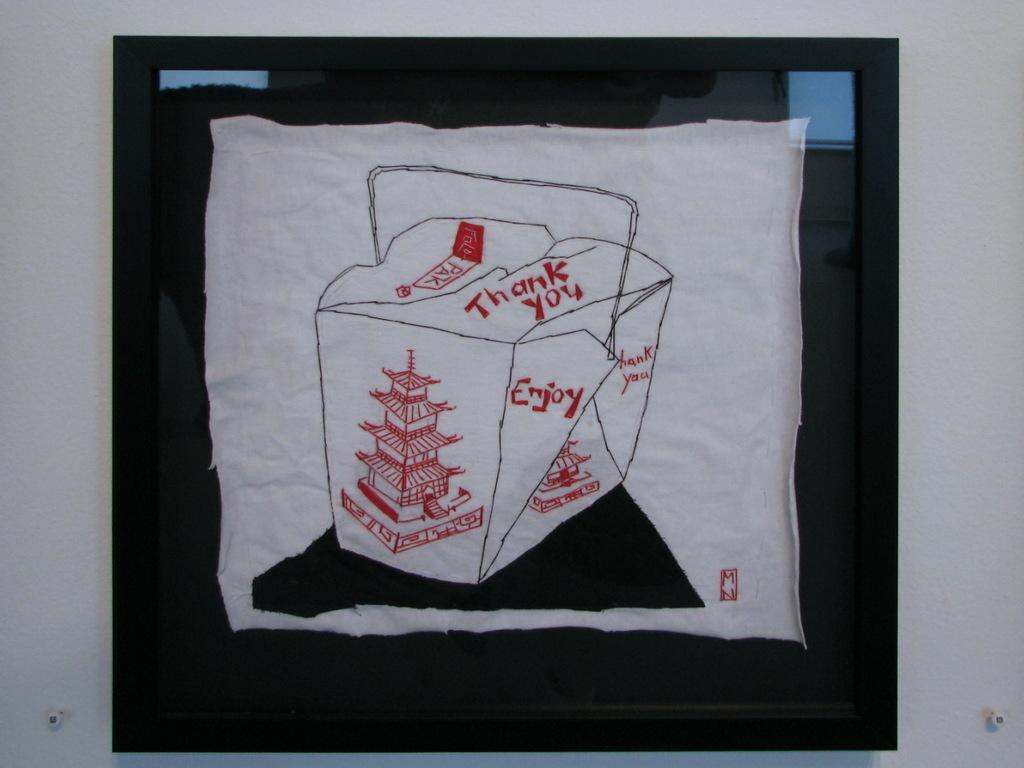What is the color of the wall in the image? The wall in the image is white. What is attached to the wall? There is a black frame on the wall. What is inside the black frame? Inside the frame, there is a white cloth. What is depicted on the white cloth? The white cloth has a painting on it. What can be seen on the painting? There is writing on the painting. What type of copper material is used to create the eye-catching design on the wall? There is no copper material or eye-catching design mentioned in the image; it features a white wall with a black frame and a painting on a white cloth. How many notes are visible on the painting? There is no mention of notes on the painting; it only has writing. 